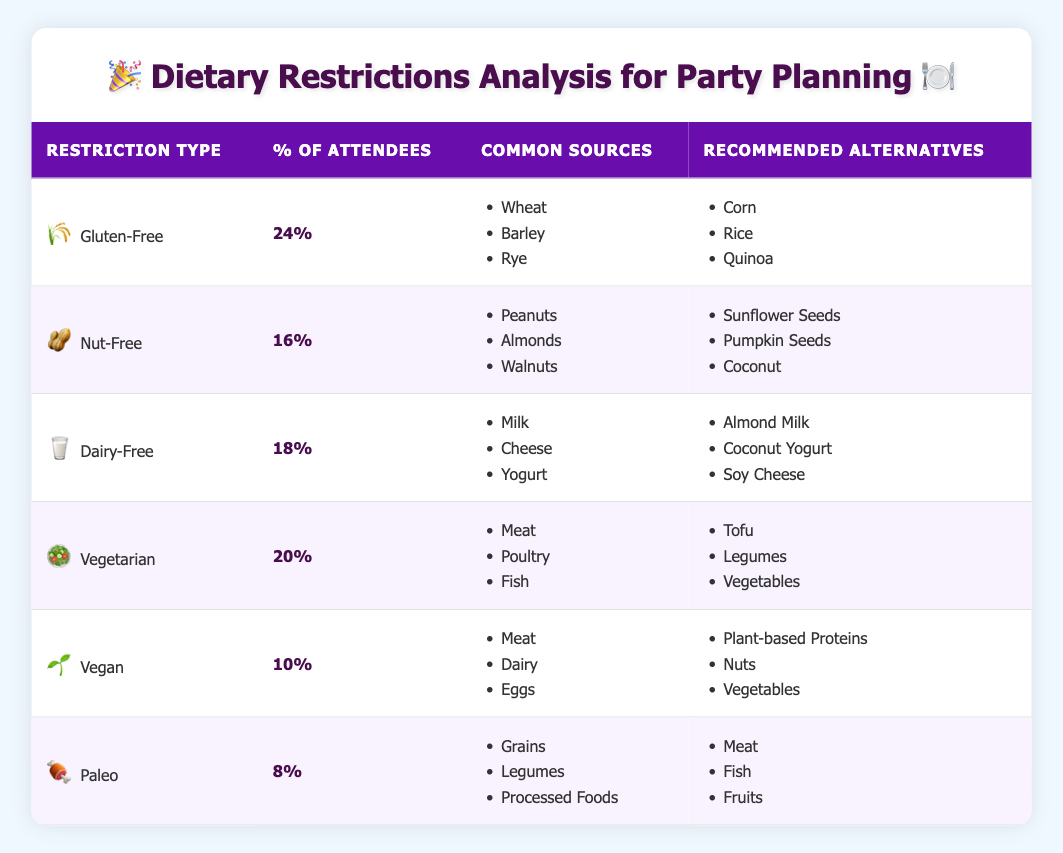What percentage of attendees have a gluten-free restriction? The table indicates that the percentage of attendees with a gluten-free restriction is listed under the "% of Attendees" column next to "Gluten-Free," which shows 24%.
Answer: 24% Which dietary restriction has the lowest percentage of attendees? Looking at the "% of Attendees" column, the "Paleo" restriction shows the lowest percentage at 8%.
Answer: 8% (Paleo) What are some common sources for dairy-free foods? The table lists "Milk," "Cheese," and "Yogurt" under the "Common Sources" for "Dairy-Free" dietary restriction.
Answer: Milk, Cheese, Yogurt If you combine the percentages of attendees with vegan and paleo restrictions, what is the total? The percentages for Vegan and Paleo are 10% and 8%, respectively. Adding these together gives us 10 + 8 = 18%.
Answer: 18% Is there a higher percentage of vegetarian attendees compared to nut-free attendees? The vegetarian percentage is 20%, while the nut-free percentage is 16%. Since 20% is greater than 16%, the answer is yes.
Answer: Yes What recommended alternatives are suggested for nut-free attendees? The table provides "Sunflower Seeds," "Pumpkin Seeds," and "Coconut" as recommended alternatives for those with nut-free restrictions.
Answer: Sunflower Seeds, Pumpkin Seeds, Coconut Which dietary restrictions have recommended alternatives that include plant-based options? The "Dairy-Free" and "Vegan" dietary restrictions both have recommended alternatives that are plant-based. "Dairy-Free" suggests almond milk and coconut yogurt, while "Vegan" includes plant-based proteins.
Answer: Dairy-Free, Vegan Calculate the average percentage of attendees across all dietary restrictions. Adding all percentages: 24 (Gluten-Free) + 16 (Nut-Free) + 18 (Dairy-Free) + 20 (Vegetarian) + 10 (Vegan) + 8 (Paleo) gives us 96. Dividing by the number of restrictions (6), we get an average of 16%.
Answer: 16% How many dietary restrictions have recommended alternatives that are grains? The table shows that "Gluten-Free" and "Paleo" have common sources that include grains. Their alternatives do not include grains, but it highlights the importance of avoiding them. Thus, we conclude there are two dietary restrictions related to grains.
Answer: 2 